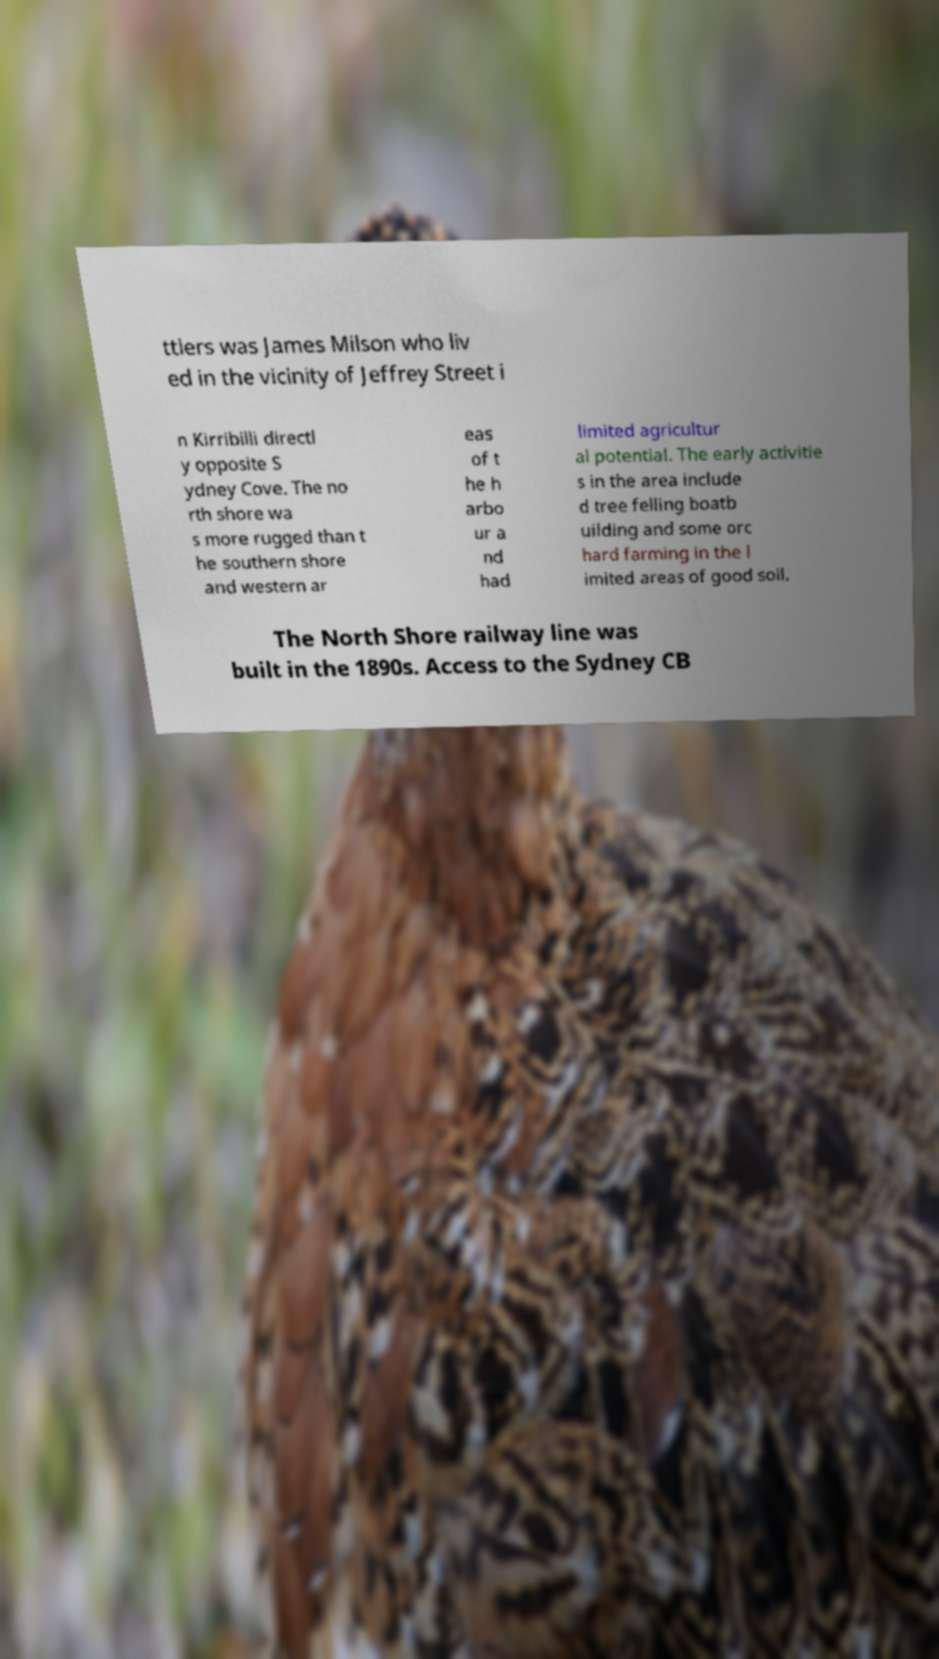Can you read and provide the text displayed in the image?This photo seems to have some interesting text. Can you extract and type it out for me? ttlers was James Milson who liv ed in the vicinity of Jeffrey Street i n Kirribilli directl y opposite S ydney Cove. The no rth shore wa s more rugged than t he southern shore and western ar eas of t he h arbo ur a nd had limited agricultur al potential. The early activitie s in the area include d tree felling boatb uilding and some orc hard farming in the l imited areas of good soil. The North Shore railway line was built in the 1890s. Access to the Sydney CB 